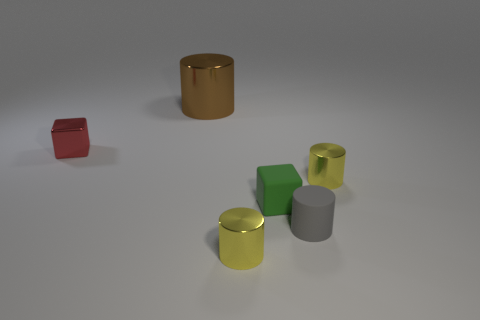There is a large metallic object that is the same shape as the tiny gray rubber object; what is its color?
Make the answer very short. Brown. How many small metallic objects have the same shape as the large object?
Give a very brief answer. 2. What number of big brown metal cylinders are there?
Ensure brevity in your answer.  1. Are there any large brown things made of the same material as the green cube?
Ensure brevity in your answer.  No. There is a yellow metallic cylinder that is in front of the small green rubber cube; is it the same size as the cylinder that is behind the small red block?
Your answer should be very brief. No. There is a brown thing that is behind the gray cylinder; what size is it?
Your response must be concise. Large. Are there any metal cubes that have the same color as the big object?
Your response must be concise. No. Is there a small matte cylinder that is to the left of the small block right of the large object?
Offer a very short reply. No. There is a matte cylinder; is its size the same as the block that is on the right side of the red block?
Your response must be concise. Yes. There is a tiny yellow shiny object in front of the tiny cube in front of the red metallic cube; is there a large brown object that is behind it?
Provide a short and direct response. Yes. 